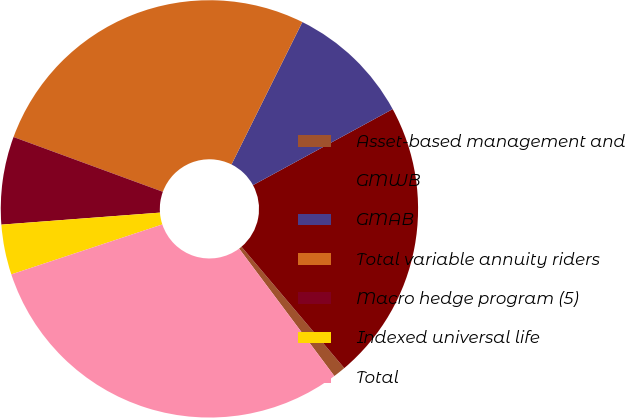<chart> <loc_0><loc_0><loc_500><loc_500><pie_chart><fcel>Asset-based management and<fcel>GMWB<fcel>GMAB<fcel>Total variable annuity riders<fcel>Macro hedge program (5)<fcel>Indexed universal life<fcel>Total<nl><fcel>0.97%<fcel>21.75%<fcel>9.72%<fcel>26.75%<fcel>6.8%<fcel>3.88%<fcel>30.13%<nl></chart> 